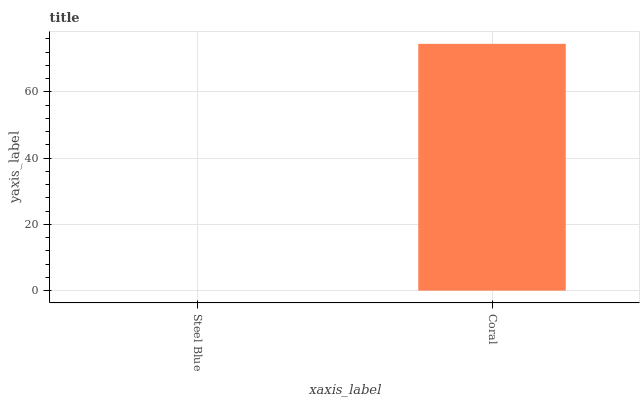Is Coral the minimum?
Answer yes or no. No. Is Coral greater than Steel Blue?
Answer yes or no. Yes. Is Steel Blue less than Coral?
Answer yes or no. Yes. Is Steel Blue greater than Coral?
Answer yes or no. No. Is Coral less than Steel Blue?
Answer yes or no. No. Is Coral the high median?
Answer yes or no. Yes. Is Steel Blue the low median?
Answer yes or no. Yes. Is Steel Blue the high median?
Answer yes or no. No. Is Coral the low median?
Answer yes or no. No. 